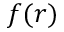<formula> <loc_0><loc_0><loc_500><loc_500>f ( r )</formula> 